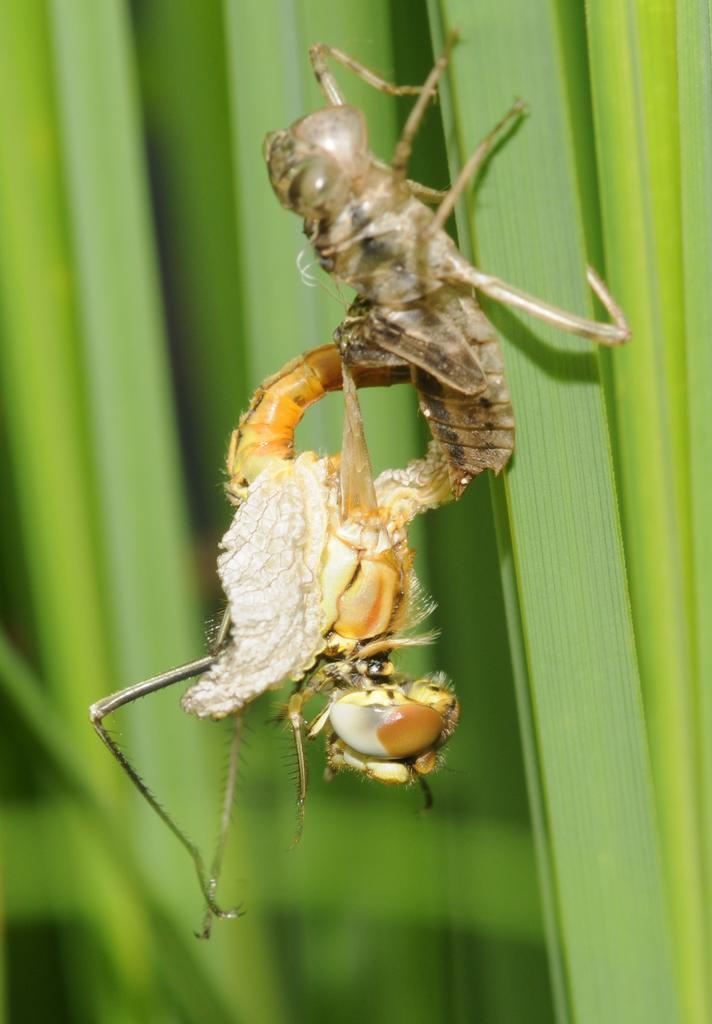Could you give a brief overview of what you see in this image? In this image I can see two insects on a plant. This image is taken may be in a garden during a day. 